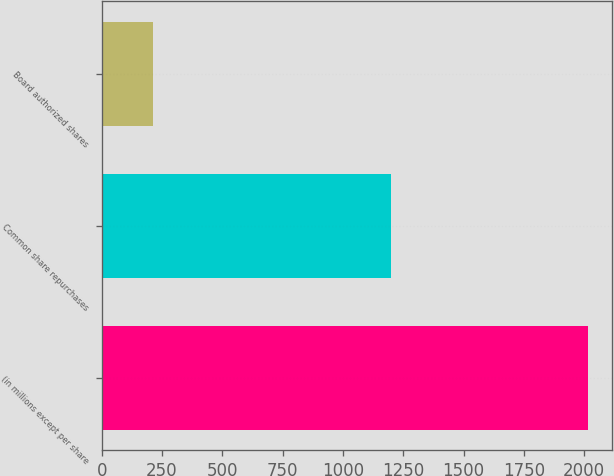Convert chart. <chart><loc_0><loc_0><loc_500><loc_500><bar_chart><fcel>(in millions except per share<fcel>Common share repurchases<fcel>Board authorized shares<nl><fcel>2015<fcel>1200<fcel>211.4<nl></chart> 